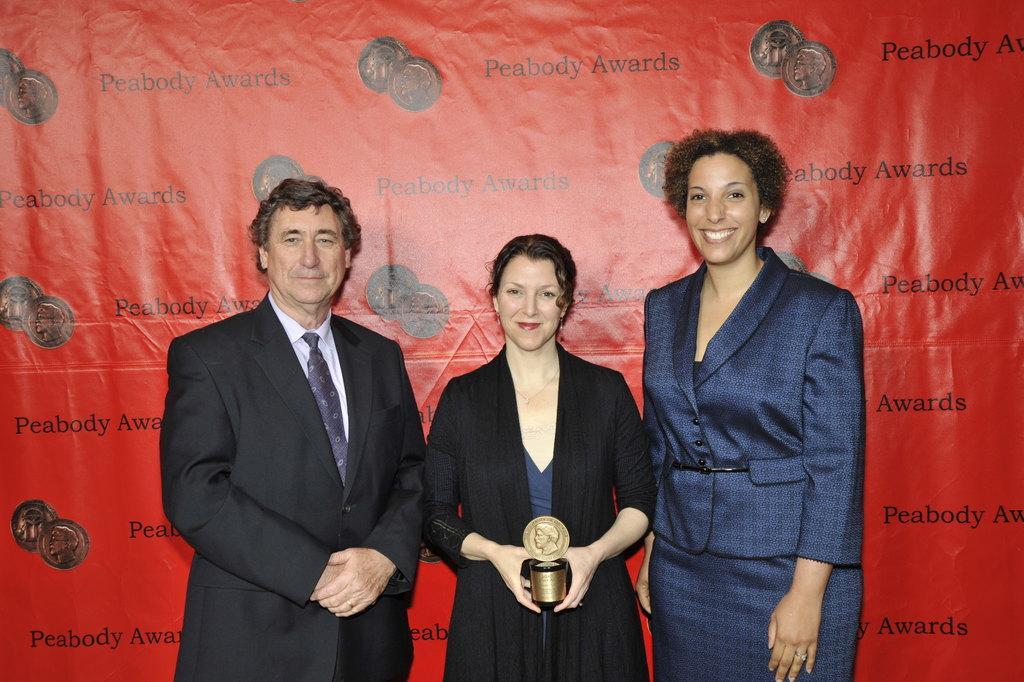Please provide a concise description of this image. In the foreground of the picture there are three people standing. In the center of the picture there is a woman holding an object. In the background there is red color banner. 